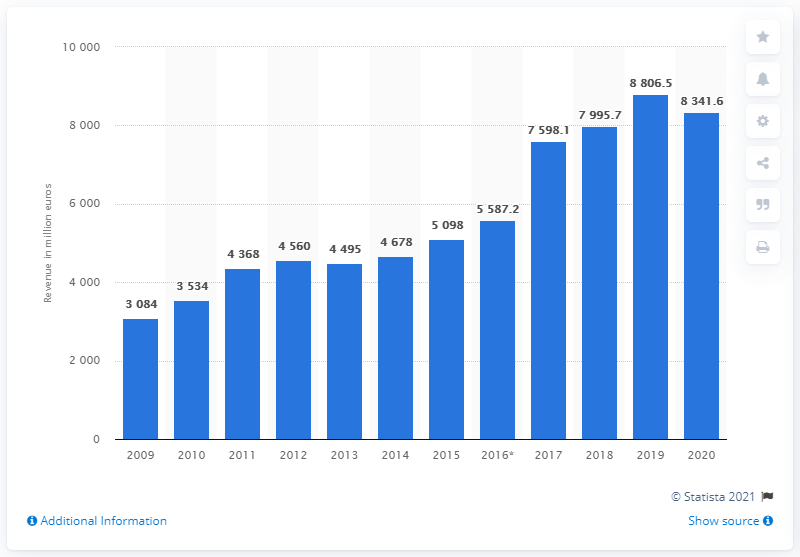Identify some key points in this picture. The last fiscal year for KION was 2009. KION's revenue in the fiscal year of 2020 was $8,341.6 million. 